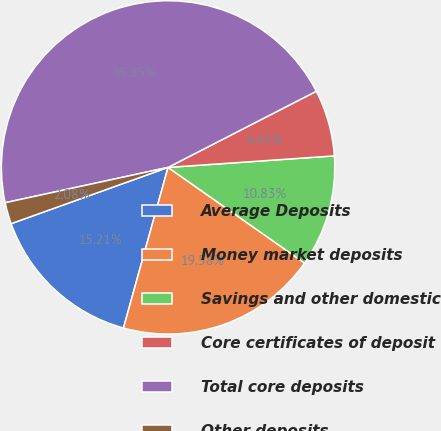<chart> <loc_0><loc_0><loc_500><loc_500><pie_chart><fcel>Average Deposits<fcel>Money market deposits<fcel>Savings and other domestic<fcel>Core certificates of deposit<fcel>Total core deposits<fcel>Other deposits<nl><fcel>15.21%<fcel>19.58%<fcel>10.83%<fcel>6.45%<fcel>45.85%<fcel>2.08%<nl></chart> 